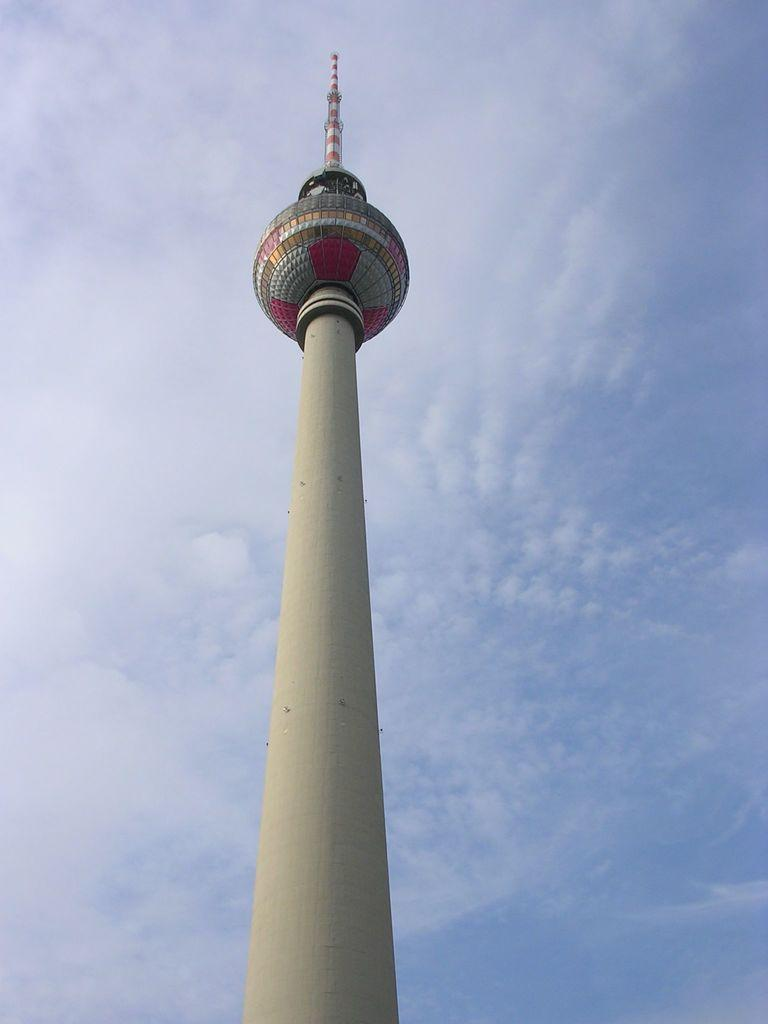What is the main subject in the center of the image? There is a tower in the center of the image. What can be seen in the background of the image? The sky is visible in the background of the image. How many cats are playing with the invention in the image? There are no cats or inventions present in the image. 